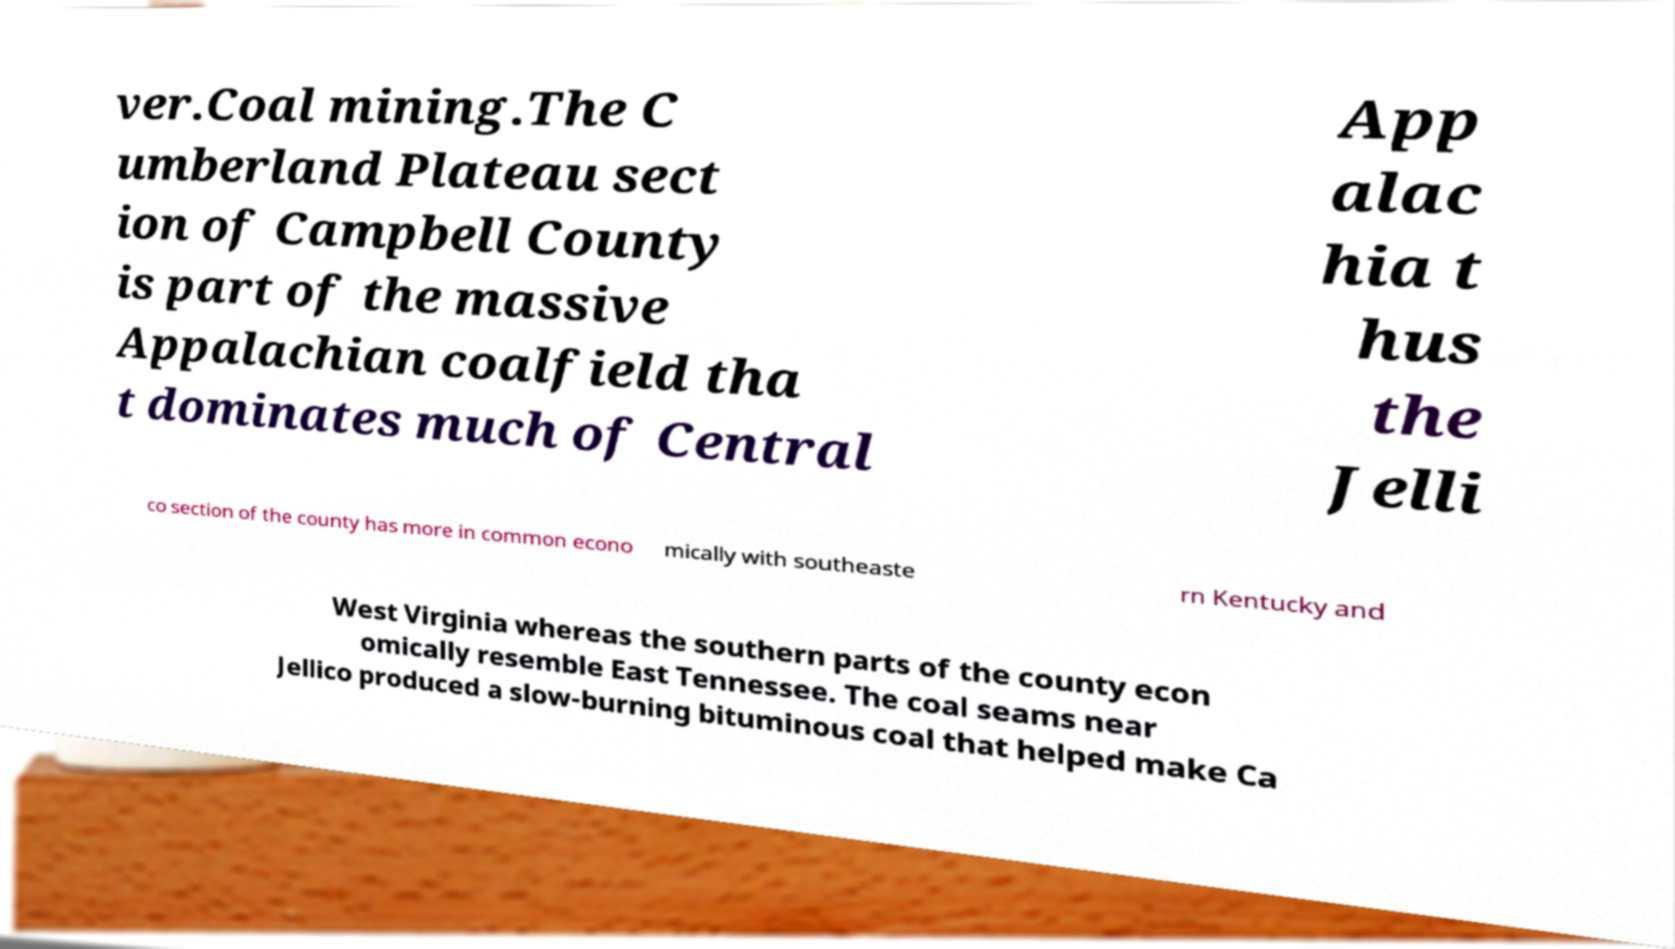Could you assist in decoding the text presented in this image and type it out clearly? ver.Coal mining.The C umberland Plateau sect ion of Campbell County is part of the massive Appalachian coalfield tha t dominates much of Central App alac hia t hus the Jelli co section of the county has more in common econo mically with southeaste rn Kentucky and West Virginia whereas the southern parts of the county econ omically resemble East Tennessee. The coal seams near Jellico produced a slow-burning bituminous coal that helped make Ca 